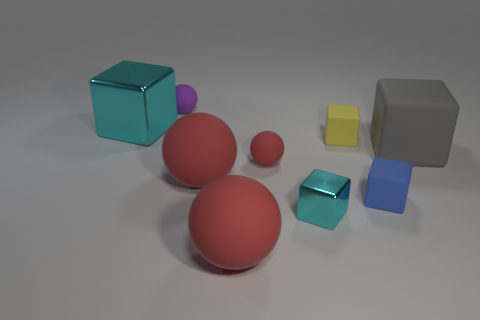Subtract all blue cylinders. How many red spheres are left? 3 Subtract 2 blocks. How many blocks are left? 3 Subtract all large gray cubes. How many cubes are left? 4 Subtract all purple balls. How many balls are left? 3 Subtract all yellow blocks. Subtract all brown cylinders. How many blocks are left? 4 Add 1 small cyan spheres. How many objects exist? 10 Subtract all blocks. How many objects are left? 4 Add 3 tiny green matte cylinders. How many tiny green matte cylinders exist? 3 Subtract 0 red cylinders. How many objects are left? 9 Subtract all large gray rubber objects. Subtract all tiny red matte objects. How many objects are left? 7 